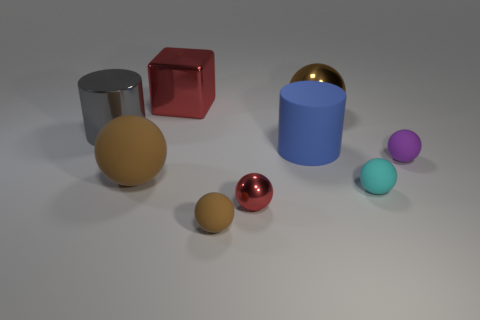Subtract all blue cylinders. How many brown spheres are left? 3 Subtract all cyan balls. How many balls are left? 5 Subtract all big matte spheres. How many spheres are left? 5 Subtract all cyan balls. Subtract all cyan cylinders. How many balls are left? 5 Add 1 large green metal cylinders. How many objects exist? 10 Subtract all balls. How many objects are left? 3 Subtract all large yellow things. Subtract all rubber objects. How many objects are left? 4 Add 4 big blue matte cylinders. How many big blue matte cylinders are left? 5 Add 2 large blue cylinders. How many large blue cylinders exist? 3 Subtract 0 green blocks. How many objects are left? 9 